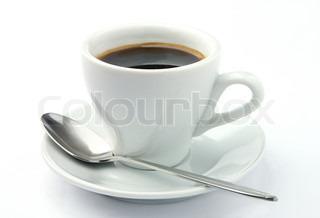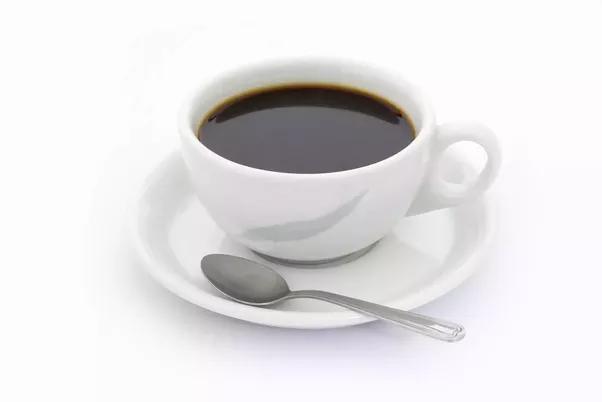The first image is the image on the left, the second image is the image on the right. Examine the images to the left and right. Is the description "There is a spoon in at least one teacup" accurate? Answer yes or no. No. The first image is the image on the left, the second image is the image on the right. Assess this claim about the two images: "The handle of a utensil sticks out of a cup of coffee in at least one image.". Correct or not? Answer yes or no. No. 